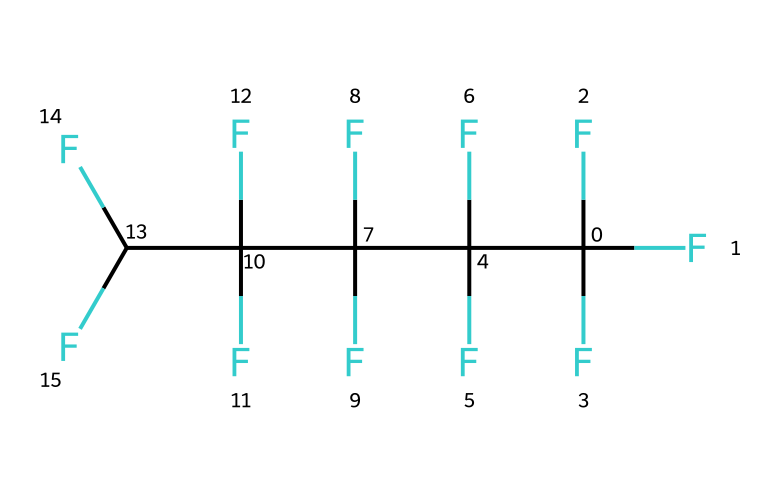What is the full name of the chemical represented by the SMILES? The SMILES representation corresponds to the arrangement of atoms in polytetrafluoroethylene, indicating the presence of multiple carbon atoms and fluorine atoms.
Answer: polytetrafluoroethylene How many carbon atoms are present in the molecule? By analyzing the SMILES, we see that there are a total of 5 carbon atoms as denoted by the 'C' at the beginning of the sequence and throughout.
Answer: 5 How many fluorine atoms are attached to the molecule? Each carbon is bonded to three fluorine atoms as represented by the 'F' in the SMILES, and with 5 carbon atoms, we multiply 5 by 4, totaling 20 fluorine atoms.
Answer: 20 What type of bond connects the carbon atoms in PTFE? The presence of carbon atoms connected by single bonds (as inferred from the structure) indicates that these carbon atoms are linked via single covalent bonds typical in saturated hydrocarbons.
Answer: single What characteristic of PTFE contributes to its non-stick properties? The high number of fluorine atoms surrounding the carbon backbone significantly contributes to the non-stick characteristic of PTFE due to the electronegative nature of fluorine which prevents adhesion of substances.
Answer: fluorine What type of material is PTFE classified as? Given the structure and the presence of long chains of carbon-fluorine bonds, PTFE is classified as a polymer, more specifically a plastic.
Answer: polymer In what type of applications is PTFE commonly used? PTFE's properties such as chemical resistance and low friction make it suitable for applications in non-stick coatings for cookware and medical instruments, where reliability and cleanliness are paramount.
Answer: coatings 